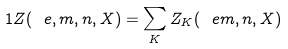<formula> <loc_0><loc_0><loc_500><loc_500>1 Z ( \ e , m , n , X ) = \sum _ { K } Z _ { K } ( \ e m , n , X )</formula> 